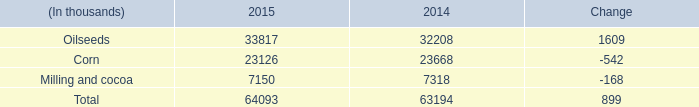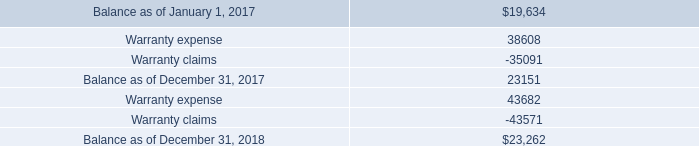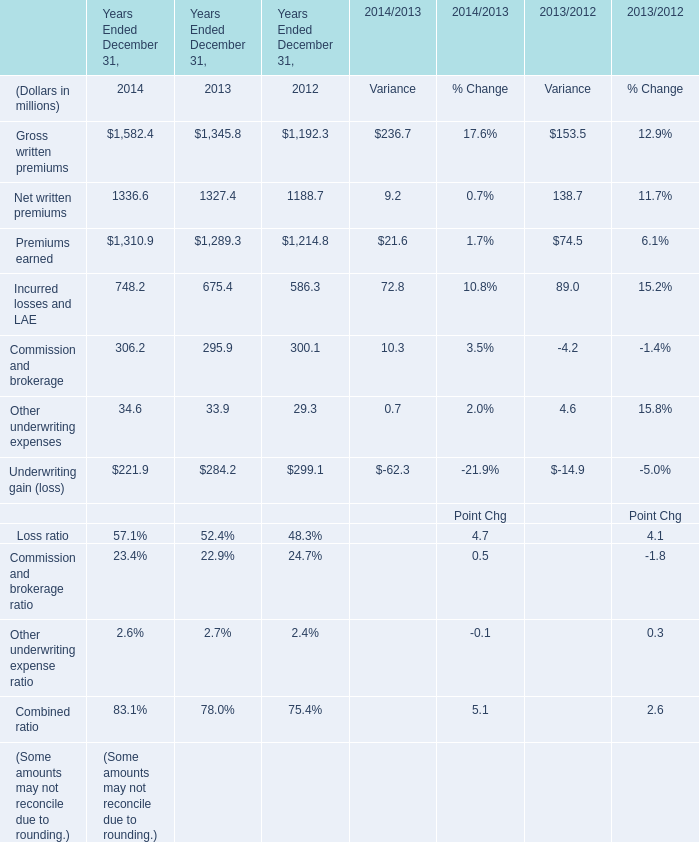What is the sum of Premiums earned of Years Ended December 31, 2013, Balance as of December 31, 2017, and Corn of 2015 ? 
Computations: ((1289.3 + 23151.0) + 23126.0)
Answer: 47566.3. 